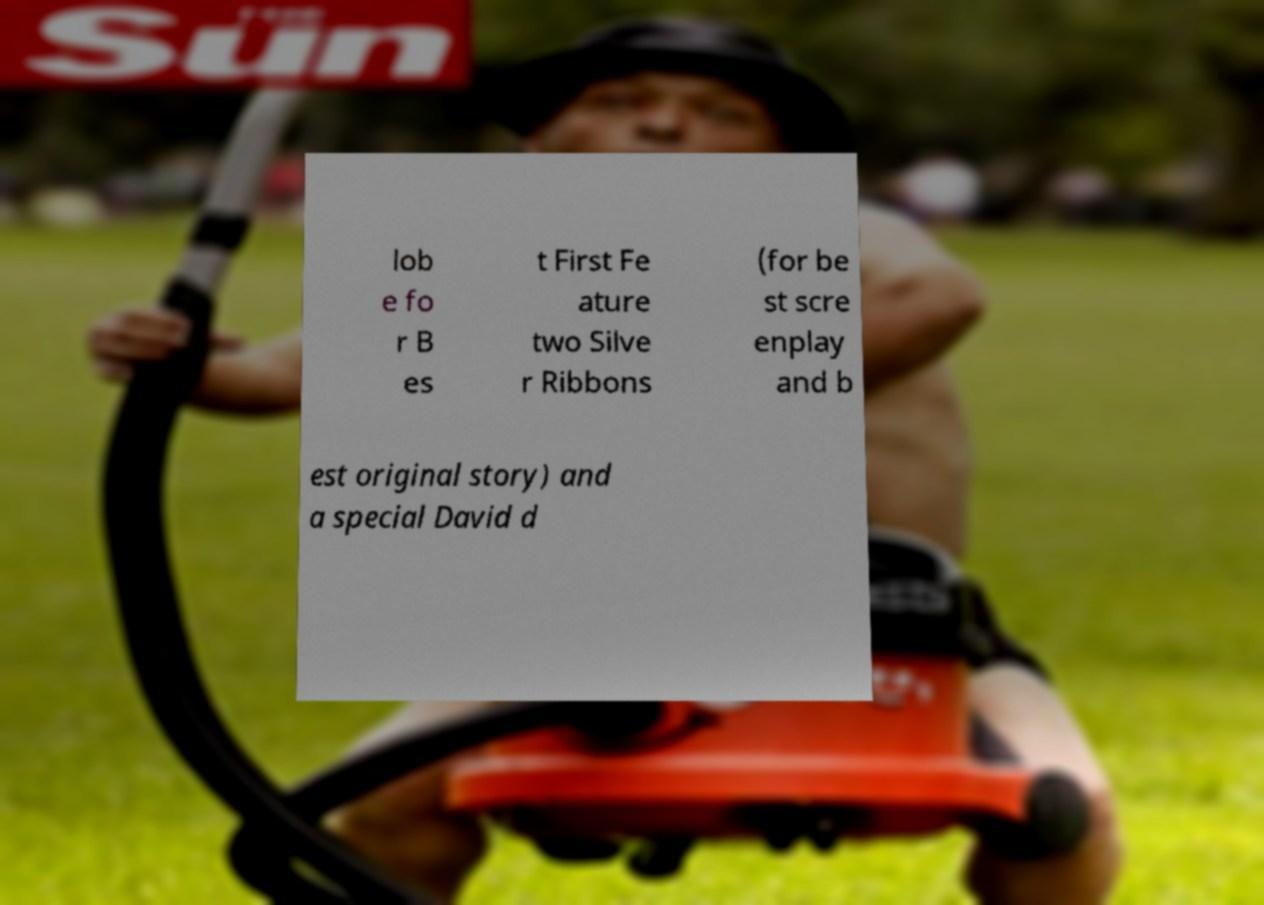Can you read and provide the text displayed in the image?This photo seems to have some interesting text. Can you extract and type it out for me? lob e fo r B es t First Fe ature two Silve r Ribbons (for be st scre enplay and b est original story) and a special David d 